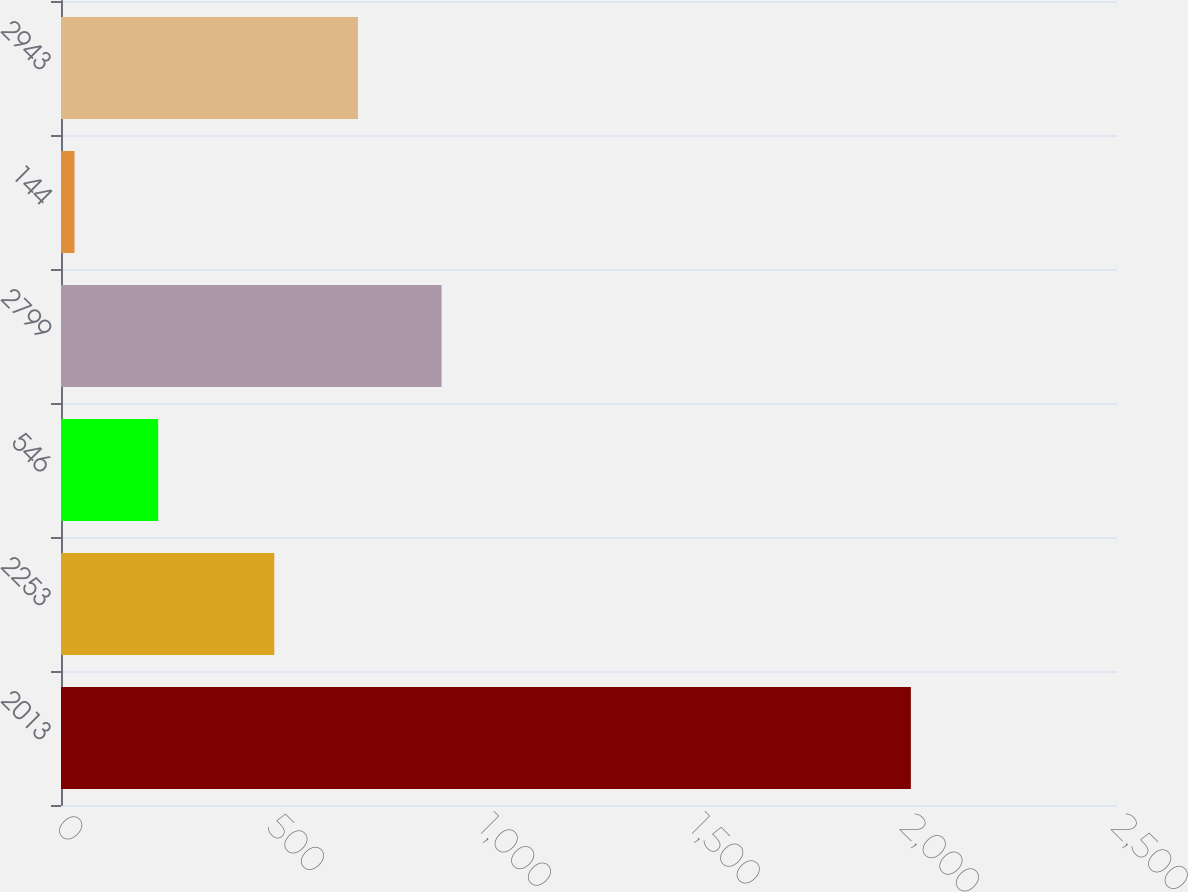<chart> <loc_0><loc_0><loc_500><loc_500><bar_chart><fcel>2013<fcel>2253<fcel>546<fcel>2799<fcel>144<fcel>2943<nl><fcel>2012<fcel>505<fcel>230<fcel>901<fcel>32<fcel>703<nl></chart> 